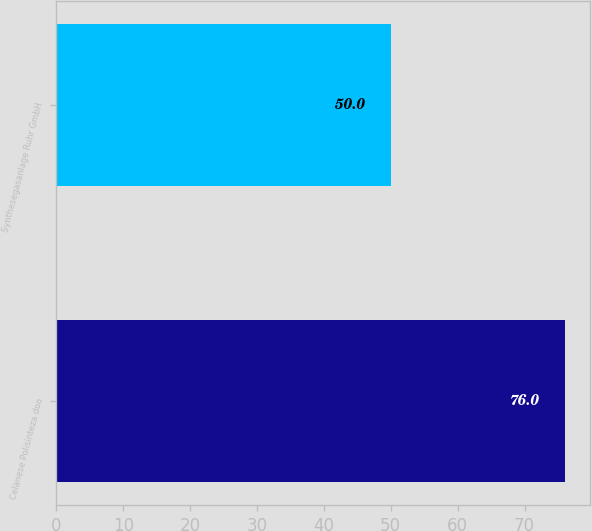Convert chart. <chart><loc_0><loc_0><loc_500><loc_500><bar_chart><fcel>Celanese Polisinteza doo<fcel>Synthesegasanlage Ruhr GmbH<nl><fcel>76<fcel>50<nl></chart> 